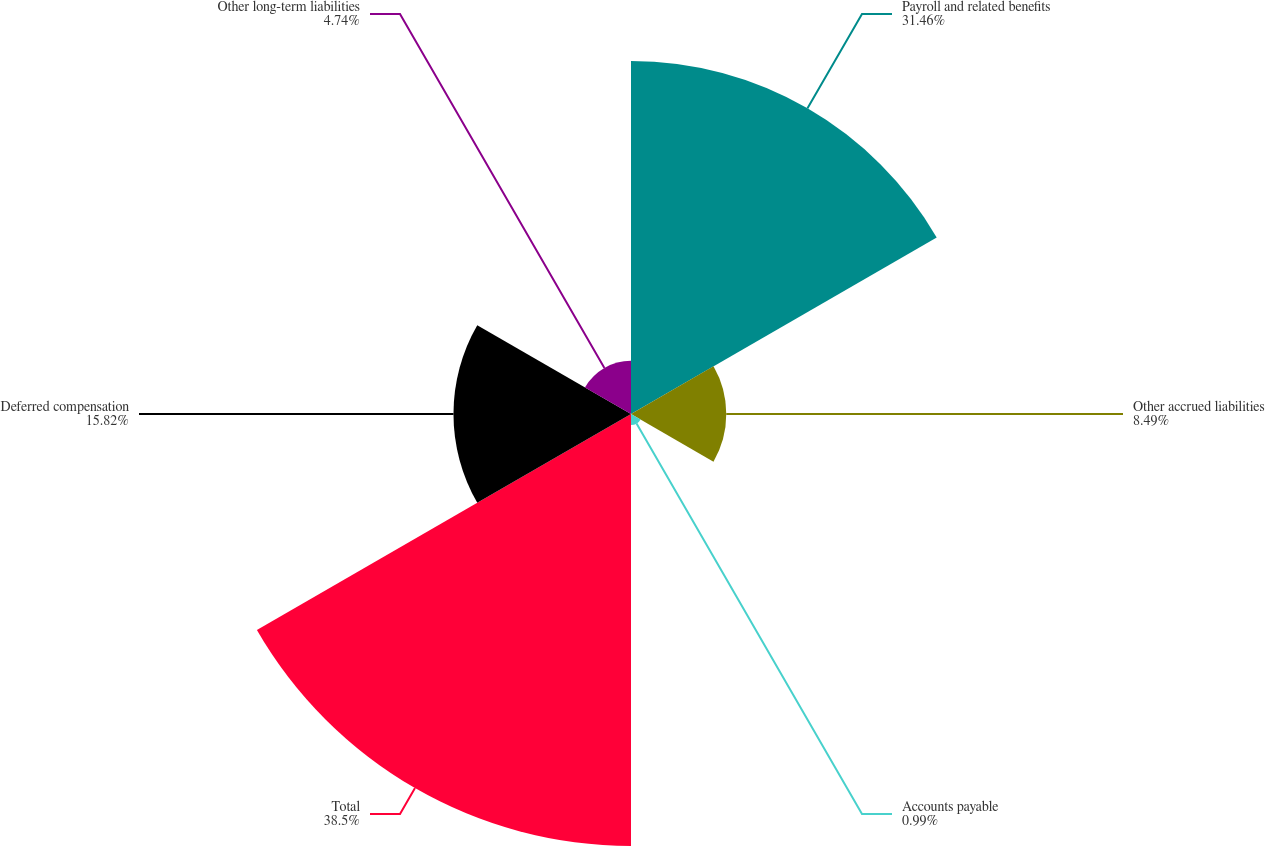Convert chart to OTSL. <chart><loc_0><loc_0><loc_500><loc_500><pie_chart><fcel>Payroll and related benefits<fcel>Other accrued liabilities<fcel>Accounts payable<fcel>Total<fcel>Deferred compensation<fcel>Other long-term liabilities<nl><fcel>31.46%<fcel>8.49%<fcel>0.99%<fcel>38.5%<fcel>15.82%<fcel>4.74%<nl></chart> 